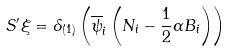Convert formula to latex. <formula><loc_0><loc_0><loc_500><loc_500>S ^ { \prime } \xi = \delta _ { ( 1 ) } \left ( \overline { \psi } _ { i } \left ( N _ { i } - \frac { 1 } { 2 } \alpha B _ { i } \right ) \right )</formula> 